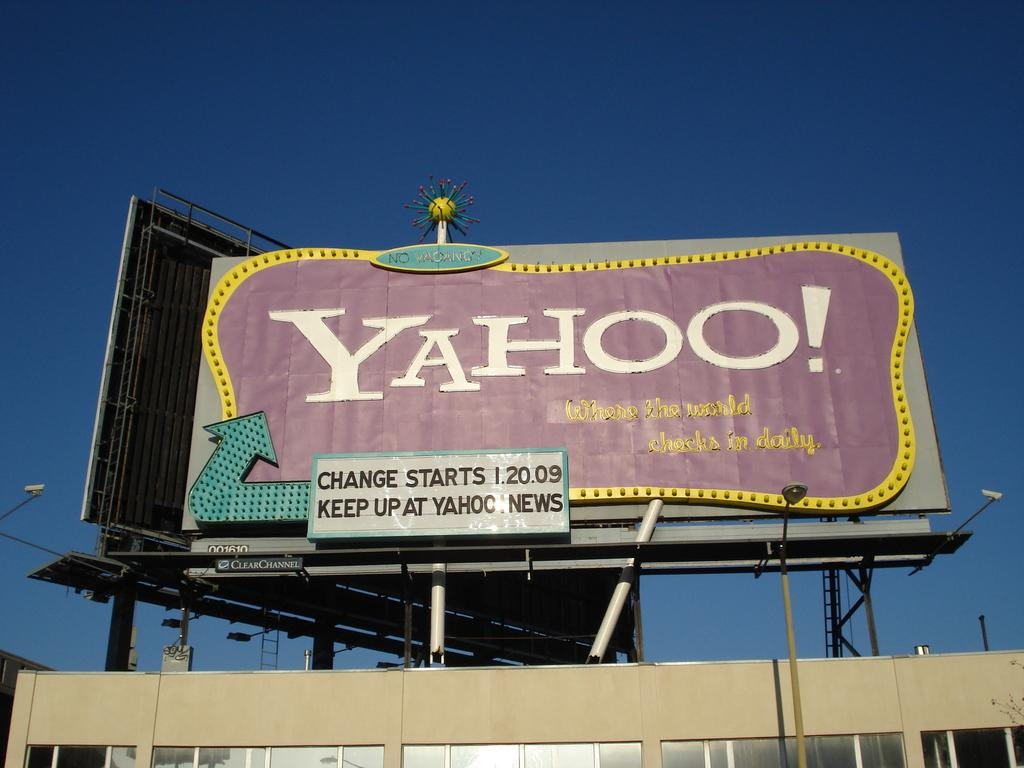<image>
Describe the image concisely. A large faded billboard is for the Yahoo! company. 